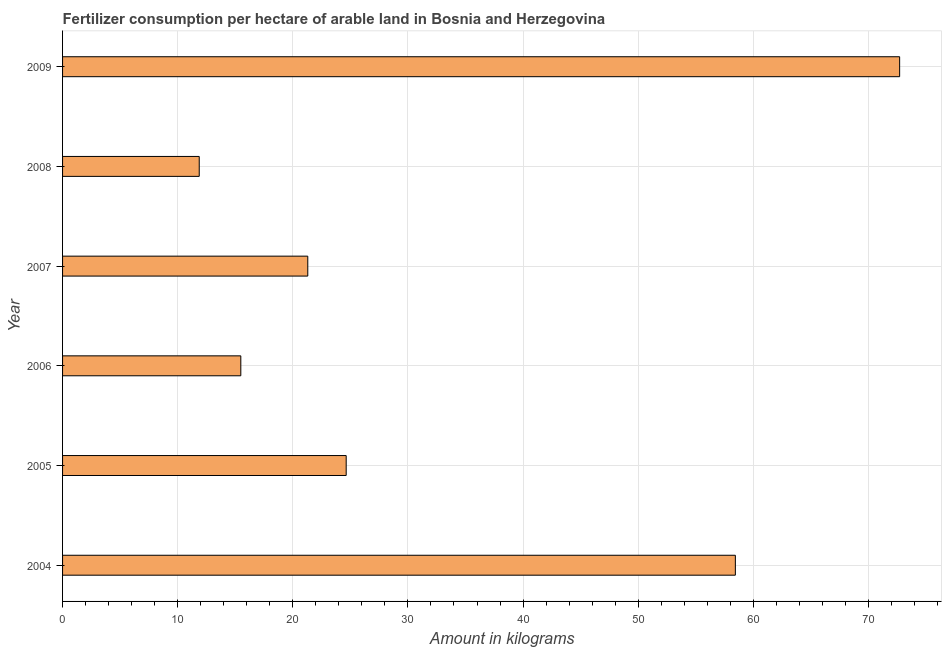Does the graph contain any zero values?
Your response must be concise. No. Does the graph contain grids?
Keep it short and to the point. Yes. What is the title of the graph?
Offer a very short reply. Fertilizer consumption per hectare of arable land in Bosnia and Herzegovina . What is the label or title of the X-axis?
Offer a very short reply. Amount in kilograms. What is the amount of fertilizer consumption in 2005?
Your answer should be compact. 24.64. Across all years, what is the maximum amount of fertilizer consumption?
Ensure brevity in your answer.  72.71. Across all years, what is the minimum amount of fertilizer consumption?
Offer a terse response. 11.87. In which year was the amount of fertilizer consumption maximum?
Your answer should be very brief. 2009. What is the sum of the amount of fertilizer consumption?
Offer a terse response. 204.45. What is the difference between the amount of fertilizer consumption in 2007 and 2009?
Your response must be concise. -51.41. What is the average amount of fertilizer consumption per year?
Your answer should be very brief. 34.08. What is the median amount of fertilizer consumption?
Keep it short and to the point. 22.97. What is the ratio of the amount of fertilizer consumption in 2006 to that in 2007?
Provide a short and direct response. 0.73. Is the amount of fertilizer consumption in 2004 less than that in 2009?
Your response must be concise. Yes. Is the difference between the amount of fertilizer consumption in 2005 and 2007 greater than the difference between any two years?
Make the answer very short. No. What is the difference between the highest and the second highest amount of fertilizer consumption?
Provide a short and direct response. 14.27. Is the sum of the amount of fertilizer consumption in 2004 and 2007 greater than the maximum amount of fertilizer consumption across all years?
Provide a succinct answer. Yes. What is the difference between the highest and the lowest amount of fertilizer consumption?
Your response must be concise. 60.84. How many bars are there?
Offer a terse response. 6. What is the difference between two consecutive major ticks on the X-axis?
Offer a very short reply. 10. Are the values on the major ticks of X-axis written in scientific E-notation?
Provide a succinct answer. No. What is the Amount in kilograms in 2004?
Provide a succinct answer. 58.44. What is the Amount in kilograms in 2005?
Offer a very short reply. 24.64. What is the Amount in kilograms in 2006?
Provide a short and direct response. 15.48. What is the Amount in kilograms in 2007?
Offer a very short reply. 21.3. What is the Amount in kilograms in 2008?
Give a very brief answer. 11.87. What is the Amount in kilograms in 2009?
Provide a short and direct response. 72.71. What is the difference between the Amount in kilograms in 2004 and 2005?
Your answer should be compact. 33.81. What is the difference between the Amount in kilograms in 2004 and 2006?
Your answer should be very brief. 42.96. What is the difference between the Amount in kilograms in 2004 and 2007?
Offer a very short reply. 37.14. What is the difference between the Amount in kilograms in 2004 and 2008?
Your answer should be very brief. 46.57. What is the difference between the Amount in kilograms in 2004 and 2009?
Give a very brief answer. -14.27. What is the difference between the Amount in kilograms in 2005 and 2006?
Provide a short and direct response. 9.15. What is the difference between the Amount in kilograms in 2005 and 2007?
Your answer should be compact. 3.34. What is the difference between the Amount in kilograms in 2005 and 2008?
Provide a succinct answer. 12.77. What is the difference between the Amount in kilograms in 2005 and 2009?
Ensure brevity in your answer.  -48.08. What is the difference between the Amount in kilograms in 2006 and 2007?
Provide a short and direct response. -5.82. What is the difference between the Amount in kilograms in 2006 and 2008?
Offer a terse response. 3.61. What is the difference between the Amount in kilograms in 2006 and 2009?
Your response must be concise. -57.23. What is the difference between the Amount in kilograms in 2007 and 2008?
Offer a terse response. 9.43. What is the difference between the Amount in kilograms in 2007 and 2009?
Provide a succinct answer. -51.41. What is the difference between the Amount in kilograms in 2008 and 2009?
Provide a succinct answer. -60.84. What is the ratio of the Amount in kilograms in 2004 to that in 2005?
Provide a succinct answer. 2.37. What is the ratio of the Amount in kilograms in 2004 to that in 2006?
Your answer should be compact. 3.77. What is the ratio of the Amount in kilograms in 2004 to that in 2007?
Give a very brief answer. 2.74. What is the ratio of the Amount in kilograms in 2004 to that in 2008?
Give a very brief answer. 4.92. What is the ratio of the Amount in kilograms in 2004 to that in 2009?
Make the answer very short. 0.8. What is the ratio of the Amount in kilograms in 2005 to that in 2006?
Keep it short and to the point. 1.59. What is the ratio of the Amount in kilograms in 2005 to that in 2007?
Provide a short and direct response. 1.16. What is the ratio of the Amount in kilograms in 2005 to that in 2008?
Provide a succinct answer. 2.08. What is the ratio of the Amount in kilograms in 2005 to that in 2009?
Offer a terse response. 0.34. What is the ratio of the Amount in kilograms in 2006 to that in 2007?
Keep it short and to the point. 0.73. What is the ratio of the Amount in kilograms in 2006 to that in 2008?
Keep it short and to the point. 1.3. What is the ratio of the Amount in kilograms in 2006 to that in 2009?
Provide a succinct answer. 0.21. What is the ratio of the Amount in kilograms in 2007 to that in 2008?
Provide a succinct answer. 1.79. What is the ratio of the Amount in kilograms in 2007 to that in 2009?
Your answer should be compact. 0.29. What is the ratio of the Amount in kilograms in 2008 to that in 2009?
Your response must be concise. 0.16. 